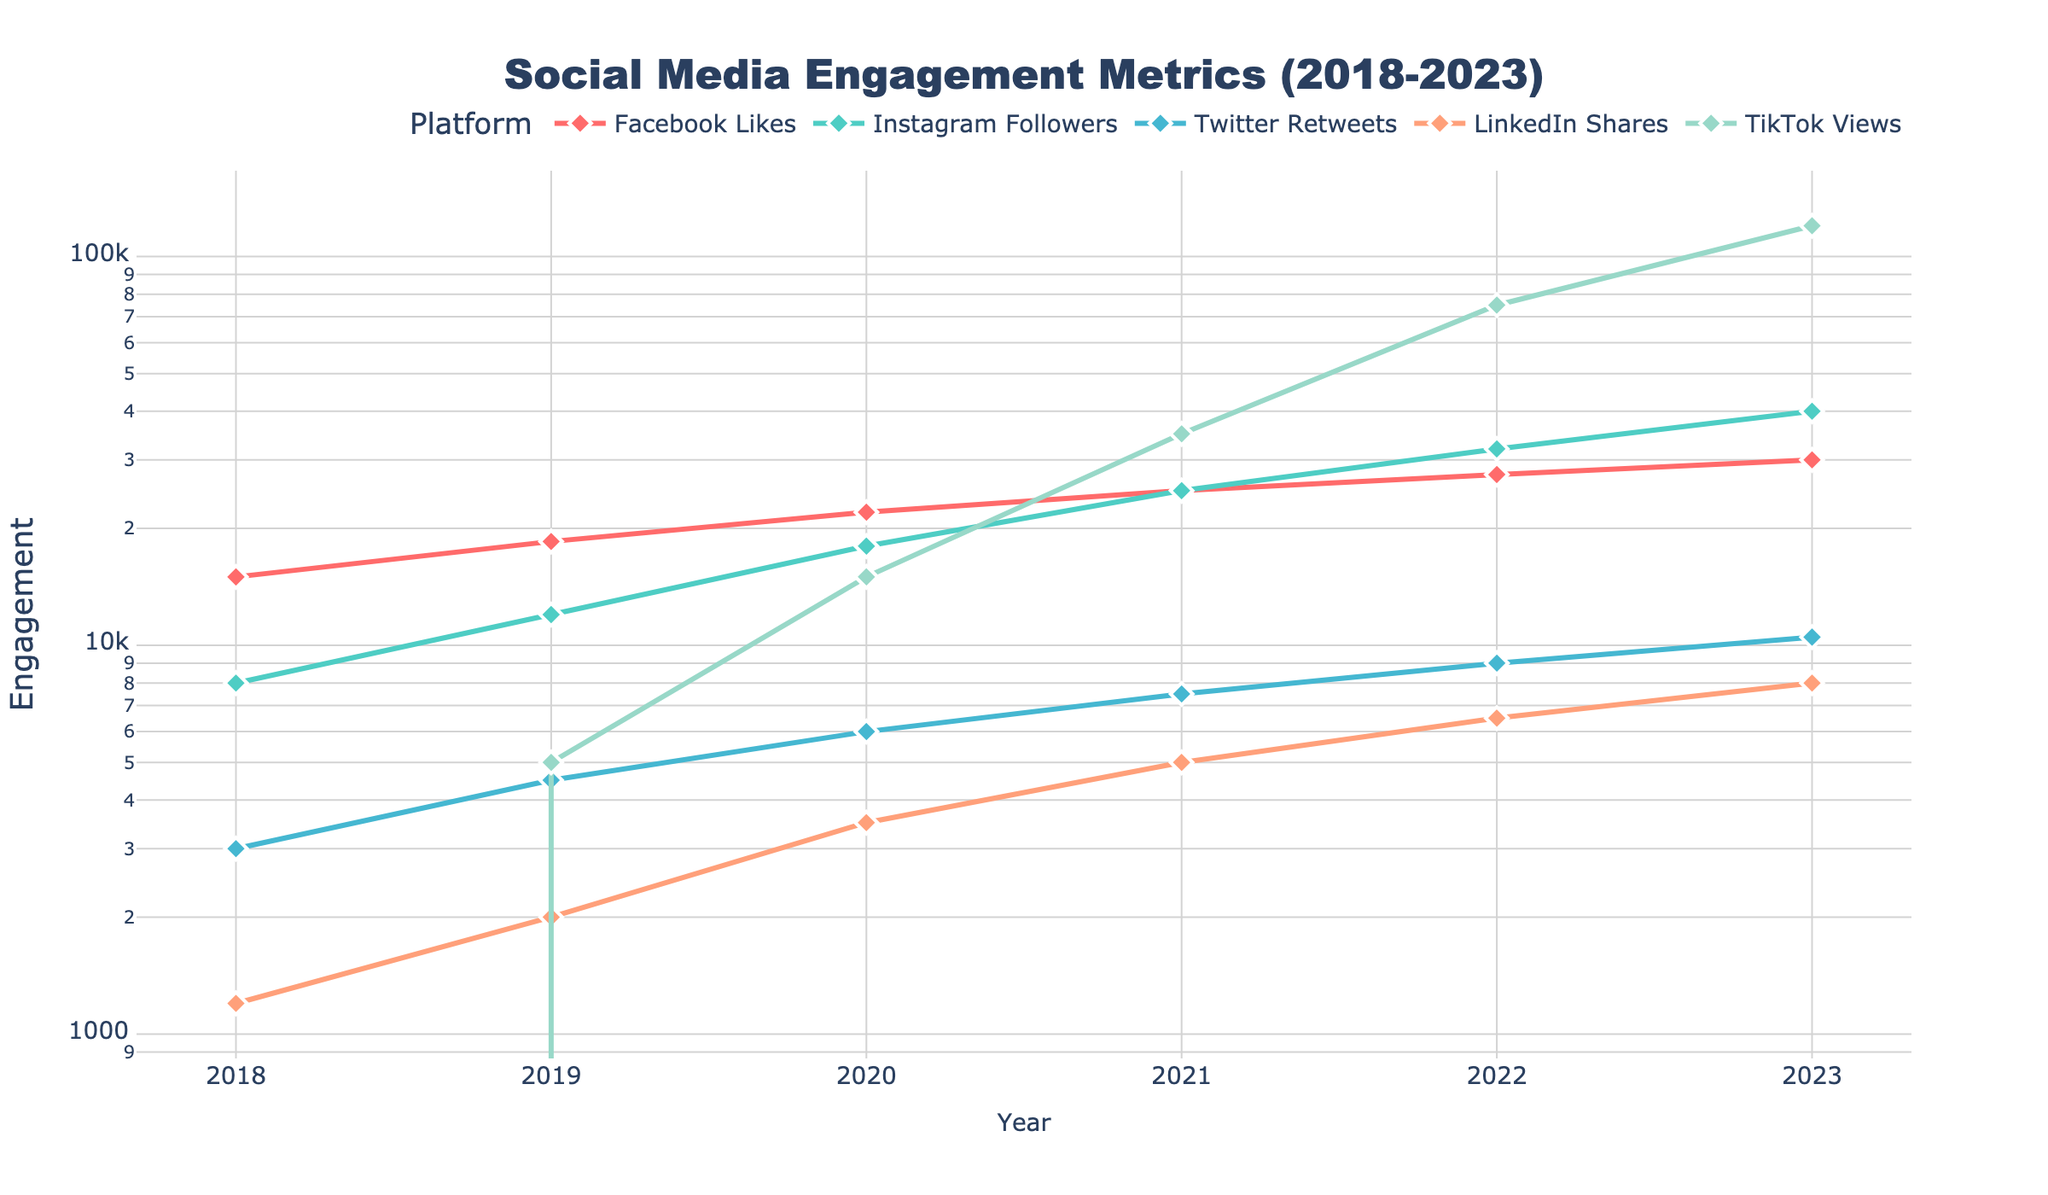What's the trend in Facebook Likes from 2018 to 2023? From the visual, we see that Facebook Likes increased every year without any dips. Start at 15,000 in 2018 and end at 30,000 in 2023.
Answer: Increasing Did Instagram Followers experience the largest absolute growth among all platforms? In 2018, Instagram Followers were 8,000 and grew to 40,000 by 2023, an increase of 32,000. TikTok Views grew from 0 in 2018 to 120,000 in 2023, an increase of 120,000 which is larger. So TikTok had the largest absolute growth.
Answer: No Which platform reached 10,000 engagement first? In 2019, Instagram reached 12,000, while Facebook reached 18,500. By 2020, Twitter reached 6,000, and LinkedIn reached 3,500. TikTok reached above 10,000 in 2020, so Instagram was the first to surpass 10,000 engagements in 2019.
Answer: Instagram Which platform had the most engagement in 2023? Looking at 2023, TikTok Views lead with 120,000 followed by Instagram Followers at 40,000 and Facebook Likes at 30,000.
Answer: TikTok Compare the growth rate of LinkedIn Shares to that of Twitter Retweets between 2019 and 2022. LinkedIn Shares went from 2,000 in 2019 to 6,500 in 2022, a growth of 4,500. Twitter Retweets went from 4,500 to 9,000 in the same period, a growth of 4,500. Both had the same growth rate.
Answer: Same What was the total engagement across all platforms in 2021? Adding each platform’s 2021 engagement: Facebook (25,000) + Instagram (25,000) + Twitter (7,500) + LinkedIn (5,000) + TikTok (35,000) = 97,500.
Answer: 97,500 Between which years did TikTok Views see the highest growth rate? From 2019 to 2020, TikTok Views grew from 5,000 to 15,000: a growth of 10,000. From 2020 to 2021, it grew to 35,000: a growth of 20,000. From 2021 to 2022, it grew to 75,000: a growth of 40,000. From 2022 to 2023, it grew to 120,000: a growth of 45,000. The highest growth was between 2022 and 2023.
Answer: 2022-2023 What is the average annual growth in Instagram Followers from 2018 to 2023? Find the difference in Instagram Followers between 2018 (8,000) and 2023 (40,000): 32,000. Divide this by the number of intervals: 5 years. 32,000 / 5 = 6,400 followers per year.
Answer: 6,400 